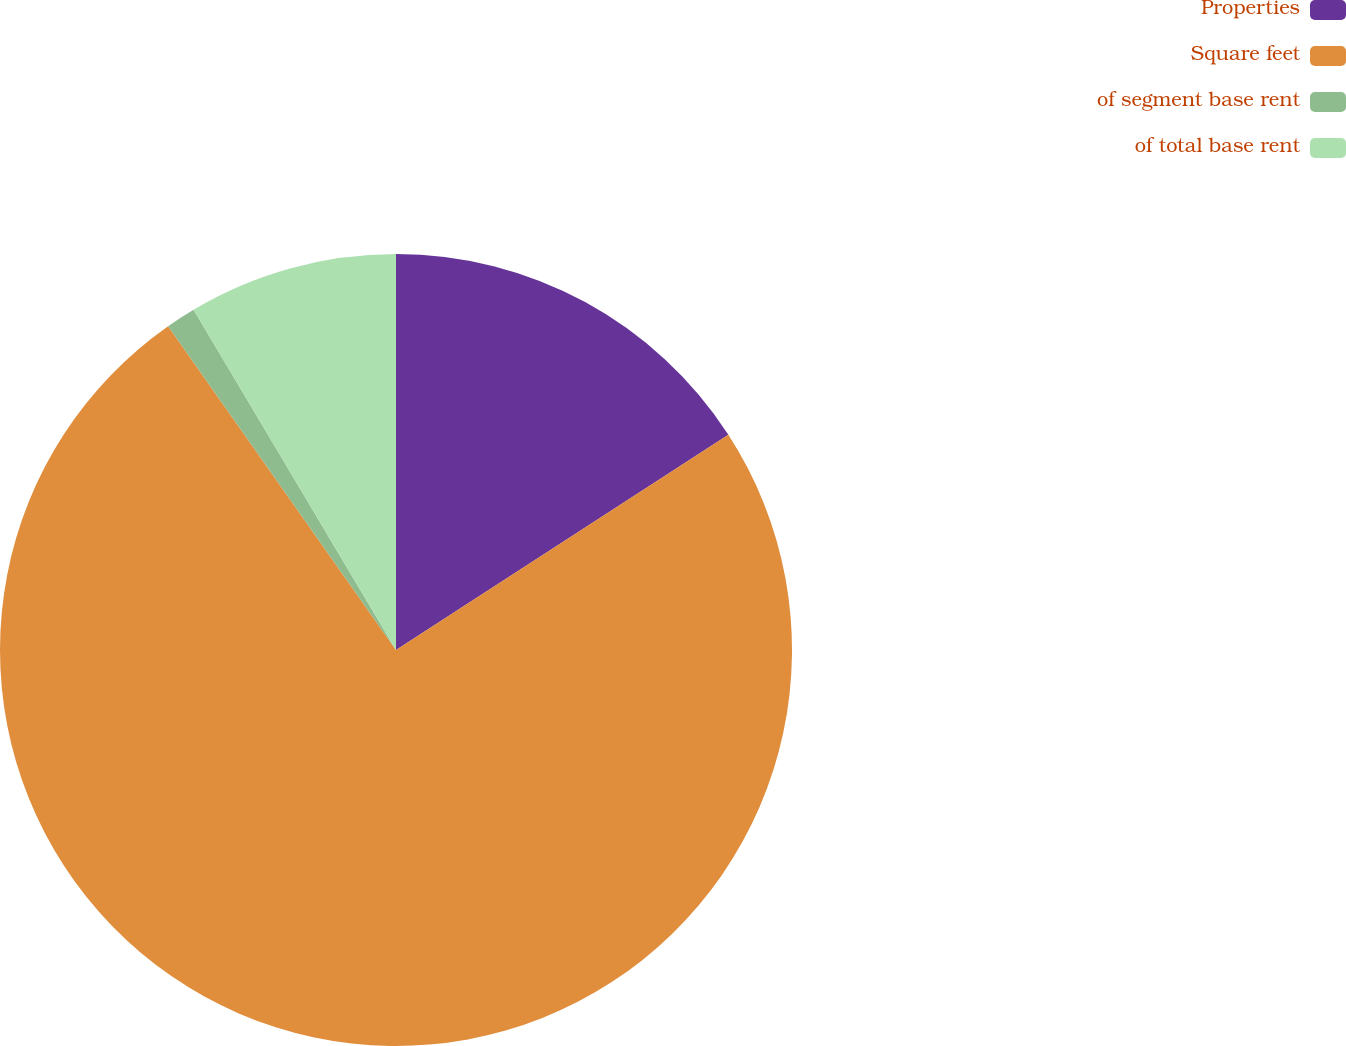Convert chart to OTSL. <chart><loc_0><loc_0><loc_500><loc_500><pie_chart><fcel>Properties<fcel>Square feet<fcel>of segment base rent<fcel>of total base rent<nl><fcel>15.85%<fcel>74.39%<fcel>1.22%<fcel>8.54%<nl></chart> 